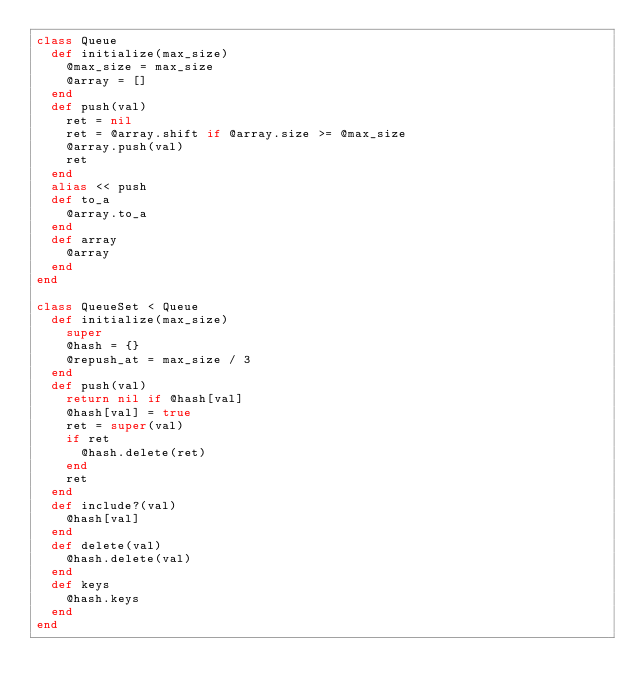Convert code to text. <code><loc_0><loc_0><loc_500><loc_500><_Ruby_>class Queue
  def initialize(max_size)
    @max_size = max_size
    @array = []
  end
  def push(val)
    ret = nil
    ret = @array.shift if @array.size >= @max_size
    @array.push(val)
    ret
  end
  alias << push
  def to_a
    @array.to_a
  end
  def array
    @array
  end
end

class QueueSet < Queue
  def initialize(max_size)
    super
    @hash = {}
    @repush_at = max_size / 3
  end
  def push(val)
    return nil if @hash[val]
    @hash[val] = true
    ret = super(val)
    if ret
      @hash.delete(ret)
    end
    ret
  end
  def include?(val)
    @hash[val]
  end
  def delete(val)
    @hash.delete(val)
  end
  def keys
    @hash.keys
  end
end
</code> 